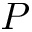Convert formula to latex. <formula><loc_0><loc_0><loc_500><loc_500>P</formula> 